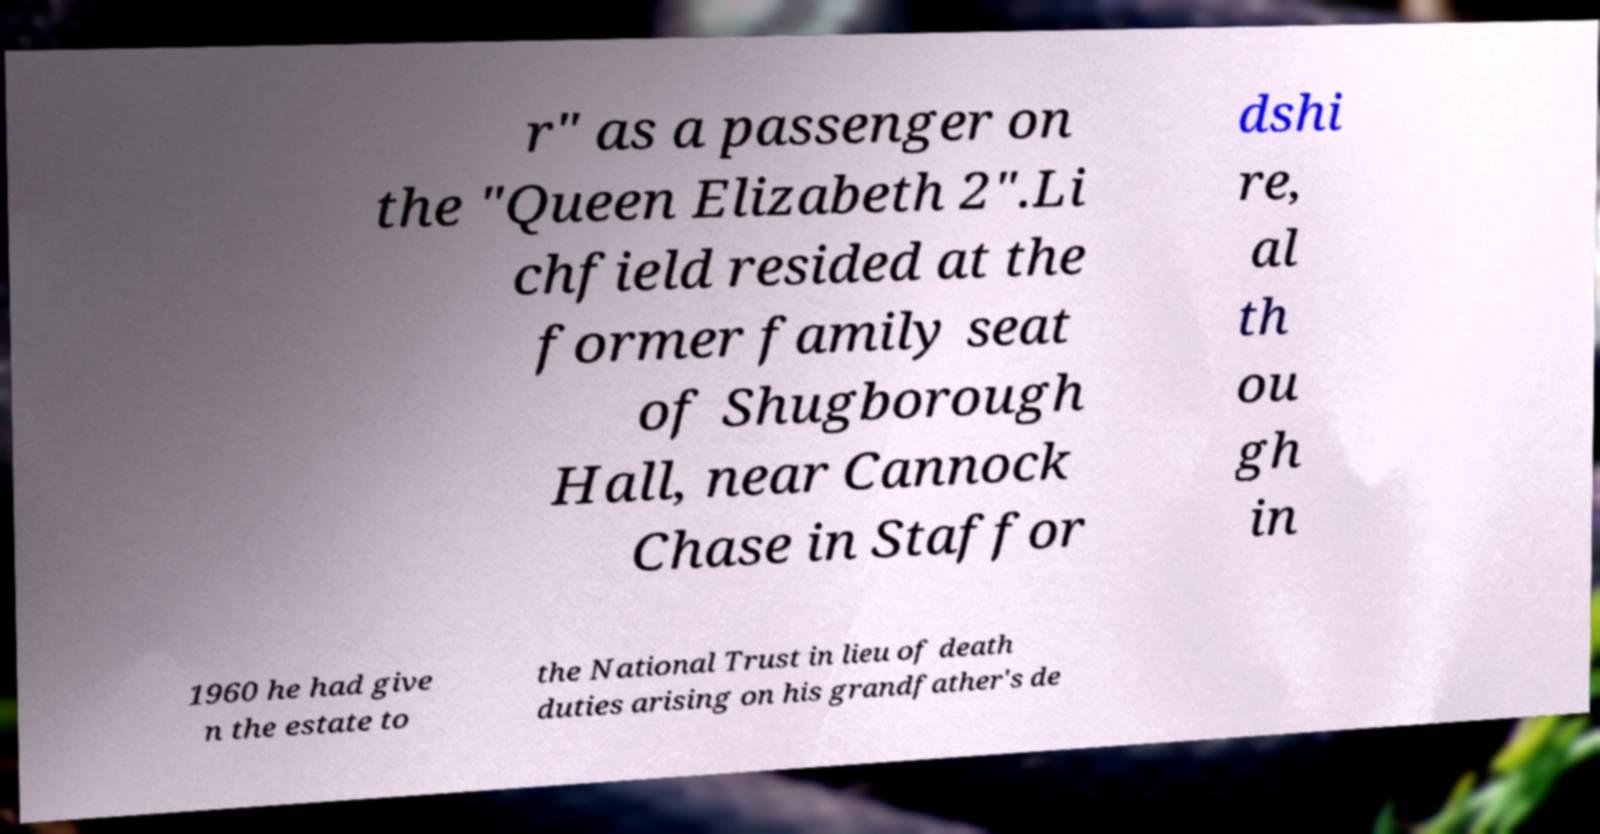What messages or text are displayed in this image? I need them in a readable, typed format. r" as a passenger on the "Queen Elizabeth 2".Li chfield resided at the former family seat of Shugborough Hall, near Cannock Chase in Staffor dshi re, al th ou gh in 1960 he had give n the estate to the National Trust in lieu of death duties arising on his grandfather's de 